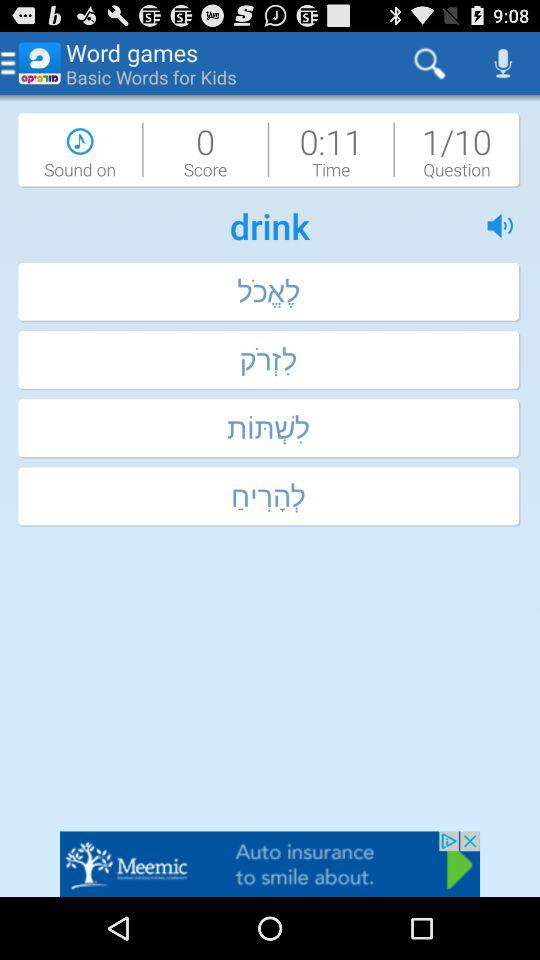What is the total amount of time left on the timer?
Answer the question using a single word or phrase. 0:11 